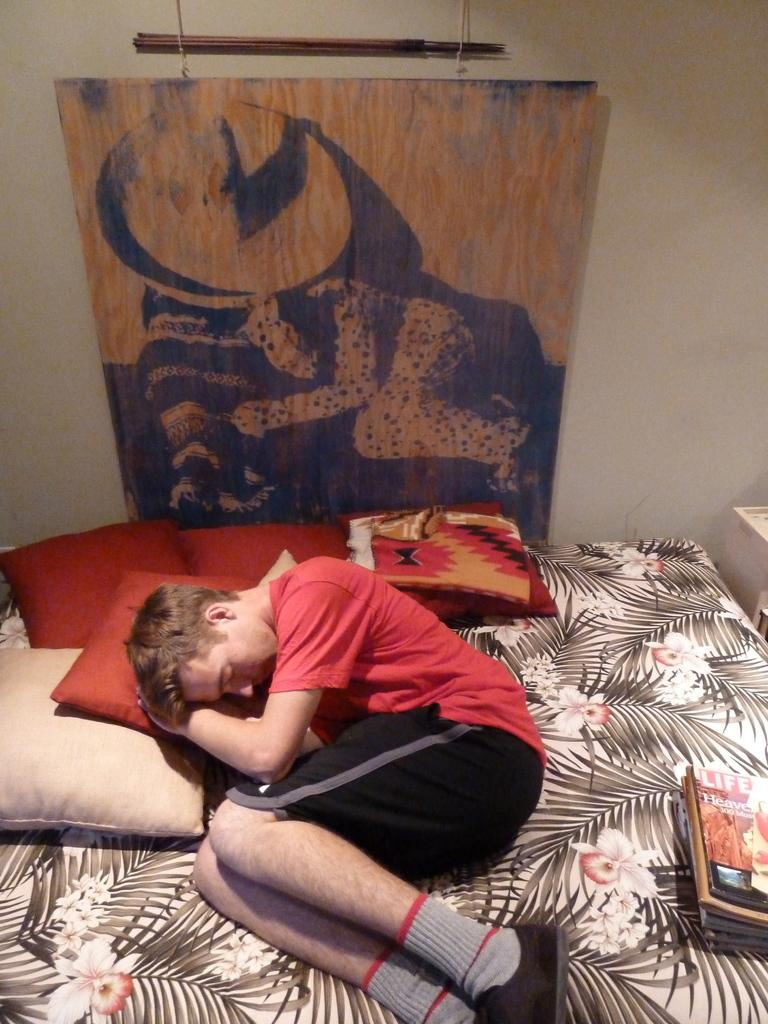What is hanging on the wall in the image? There is a poster on the wall. What is the person in the image doing? A person is sleeping on a bed. What can be found on the bed besides the person? There are pillows and books on the bed. What color is the t-shirt the person is wearing? The person is wearing a red t-shirt. How many sacks can be seen in the image? There are no sacks present in the image. What type of mountain is visible in the background of the image? There is no mountain visible in the image; it only shows a person sleeping on a bed with a poster on the wall. 